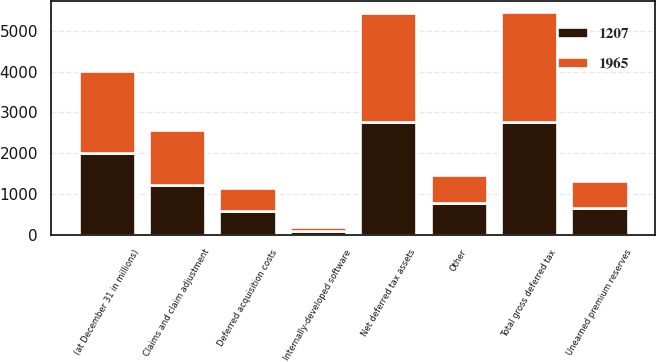Convert chart to OTSL. <chart><loc_0><loc_0><loc_500><loc_500><stacked_bar_chart><ecel><fcel>(at December 31 in millions)<fcel>Claims and claim adjustment<fcel>Unearned premium reserves<fcel>Other<fcel>Total gross deferred tax<fcel>Net deferred tax assets<fcel>Deferred acquisition costs<fcel>Internally-developed software<nl><fcel>1207<fcel>2008<fcel>1217<fcel>663<fcel>769<fcel>2754<fcel>2754<fcel>575<fcel>100<nl><fcel>1965<fcel>2007<fcel>1352<fcel>661<fcel>700<fcel>2713<fcel>2677<fcel>578<fcel>77<nl></chart> 